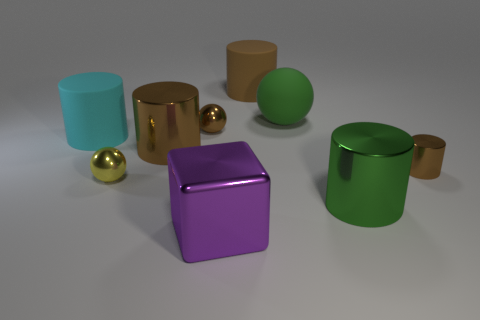Is there any other thing that has the same shape as the purple shiny thing?
Your answer should be compact. No. Does the big matte ball have the same color as the metallic block?
Ensure brevity in your answer.  No. Is the number of large shiny cylinders less than the number of metal objects?
Make the answer very short. Yes. What is the material of the small ball that is right of the yellow shiny ball?
Make the answer very short. Metal. What material is the green cylinder that is the same size as the block?
Your answer should be very brief. Metal. What material is the large brown thing in front of the big matte cylinder that is to the left of the metal thing that is in front of the big green cylinder?
Offer a very short reply. Metal. There is a brown thing that is to the right of the brown matte cylinder; is it the same size as the big green matte thing?
Ensure brevity in your answer.  No. Is the number of large things greater than the number of things?
Ensure brevity in your answer.  No. What number of big things are either brown cylinders or brown metallic cylinders?
Offer a terse response. 2. What number of other objects are there of the same color as the big rubber sphere?
Offer a terse response. 1. 